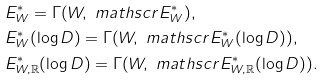Convert formula to latex. <formula><loc_0><loc_0><loc_500><loc_500>& E ^ { \ast } _ { W } = \Gamma ( W , \ m a t h s c r { E } ^ { \ast } _ { W } ) , \\ & E ^ { \ast } _ { W } ( \log D ) = \Gamma ( W , \ m a t h s c r { E } ^ { \ast } _ { W } ( \log D ) ) , \\ & E ^ { \ast } _ { W , \mathbb { R } } ( \log D ) = \Gamma ( W , \ m a t h s c r { E } ^ { \ast } _ { W , \mathbb { R } } ( \log D ) ) .</formula> 